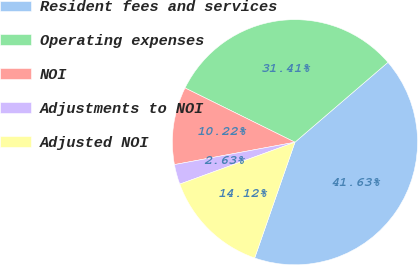Convert chart. <chart><loc_0><loc_0><loc_500><loc_500><pie_chart><fcel>Resident fees and services<fcel>Operating expenses<fcel>NOI<fcel>Adjustments to NOI<fcel>Adjusted NOI<nl><fcel>41.63%<fcel>31.41%<fcel>10.22%<fcel>2.63%<fcel>14.12%<nl></chart> 